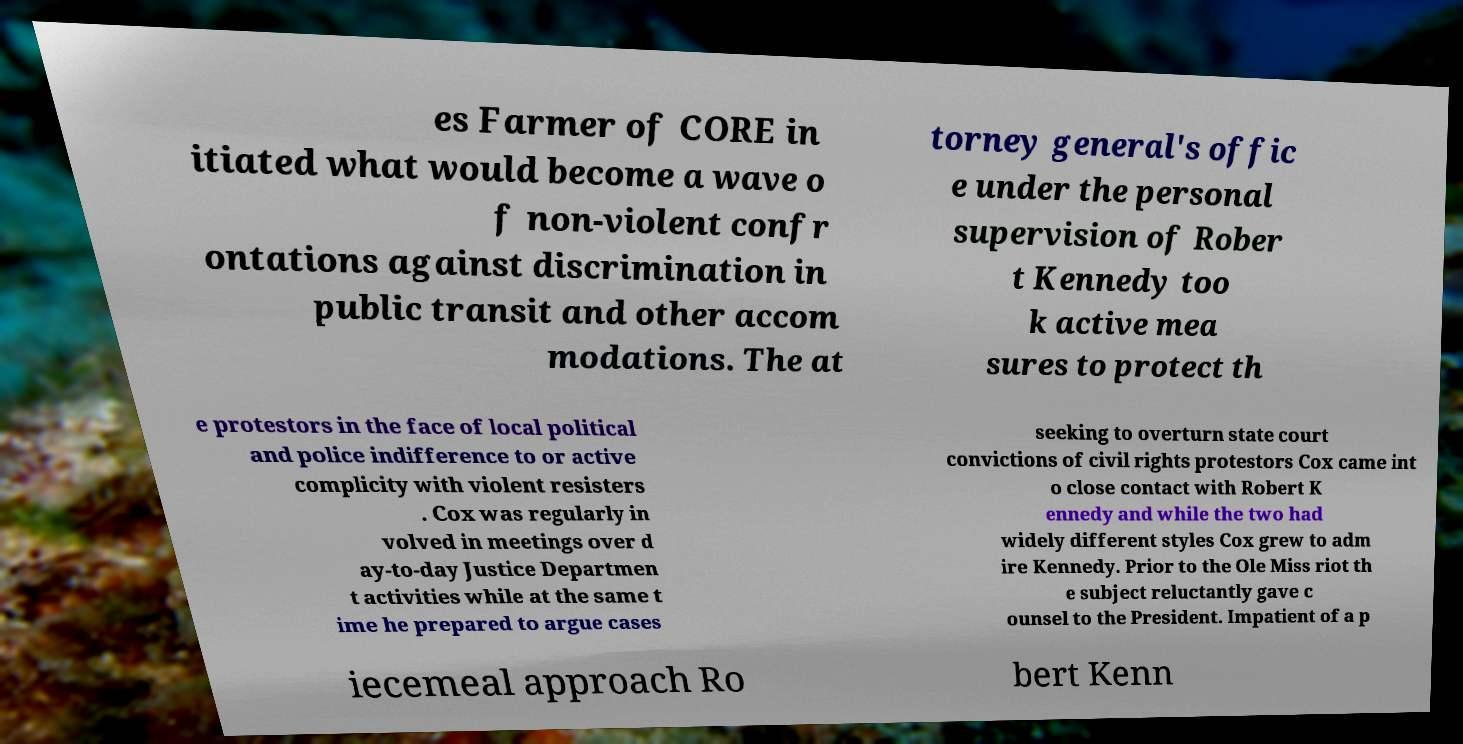I need the written content from this picture converted into text. Can you do that? es Farmer of CORE in itiated what would become a wave o f non-violent confr ontations against discrimination in public transit and other accom modations. The at torney general's offic e under the personal supervision of Rober t Kennedy too k active mea sures to protect th e protestors in the face of local political and police indifference to or active complicity with violent resisters . Cox was regularly in volved in meetings over d ay-to-day Justice Departmen t activities while at the same t ime he prepared to argue cases seeking to overturn state court convictions of civil rights protestors Cox came int o close contact with Robert K ennedy and while the two had widely different styles Cox grew to adm ire Kennedy. Prior to the Ole Miss riot th e subject reluctantly gave c ounsel to the President. Impatient of a p iecemeal approach Ro bert Kenn 